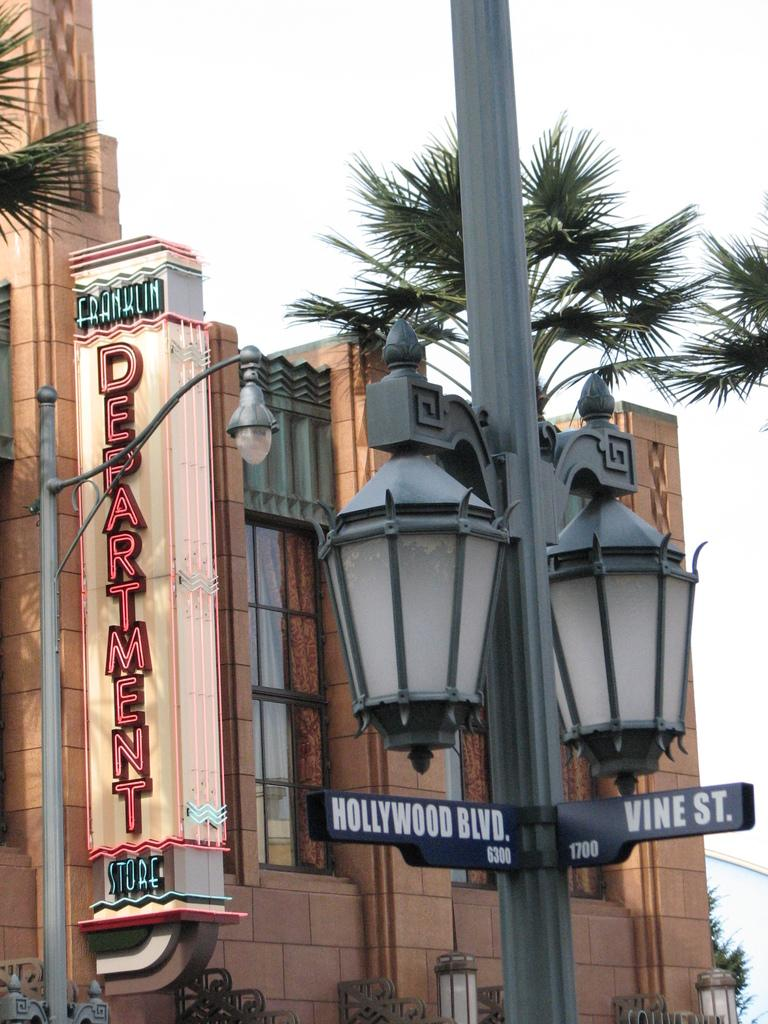<image>
Create a compact narrative representing the image presented. Street signs indicate the corner of Hollywood Blvd and Vine St. 